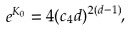<formula> <loc_0><loc_0><loc_500><loc_500>e ^ { K _ { 0 } } = 4 ( c _ { 4 } d ) ^ { 2 ( d - 1 ) } ,</formula> 